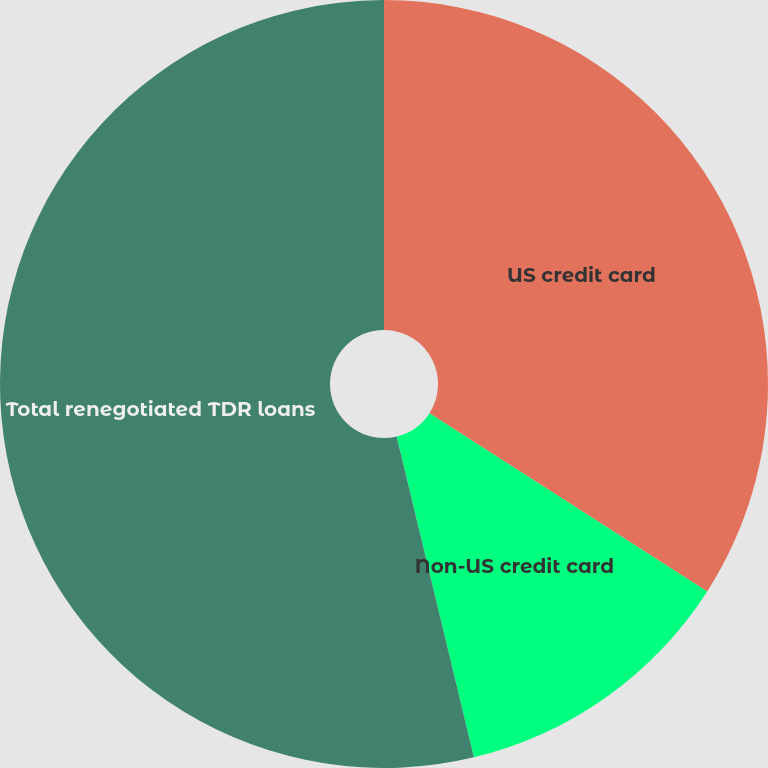Convert chart to OTSL. <chart><loc_0><loc_0><loc_500><loc_500><pie_chart><fcel>US credit card<fcel>Non-US credit card<fcel>Total renegotiated TDR loans<nl><fcel>34.08%<fcel>12.16%<fcel>53.76%<nl></chart> 